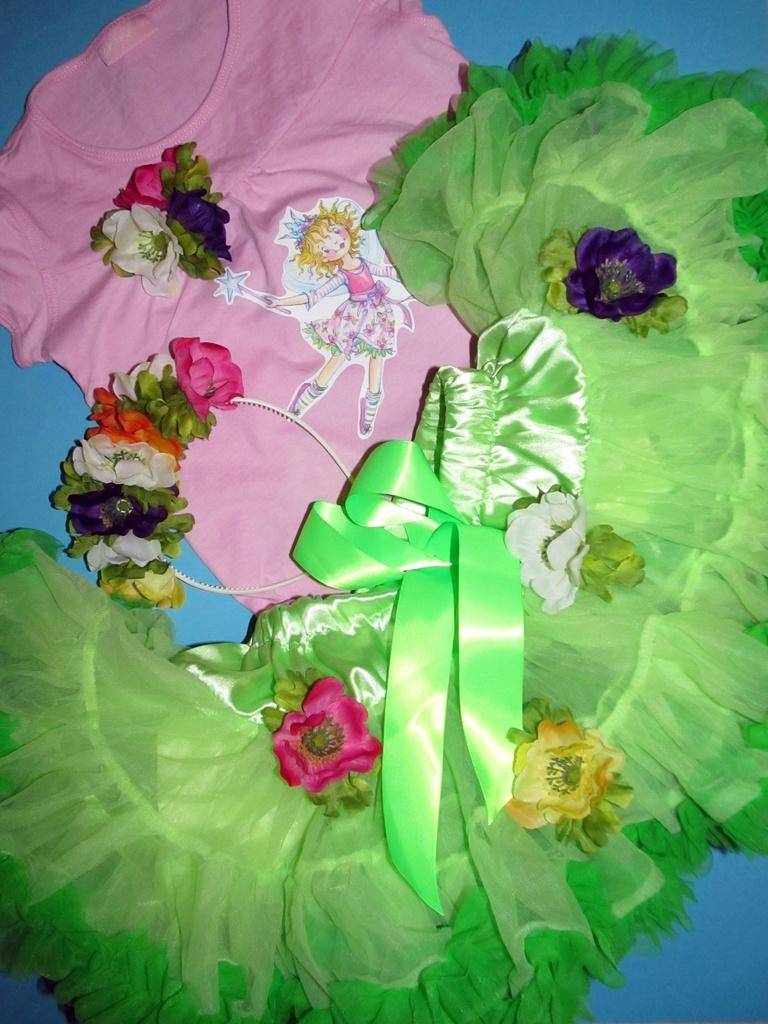What type of items are visible in the image? There are clothes and a hair band in the image. Can you describe the hair band in the image? Yes, there is a hair band in the image. What type of ball can be seen in the image? There is no ball present in the image. Is there any sleet visible in the image? There is no mention of sleet or any weather-related elements in the image. 